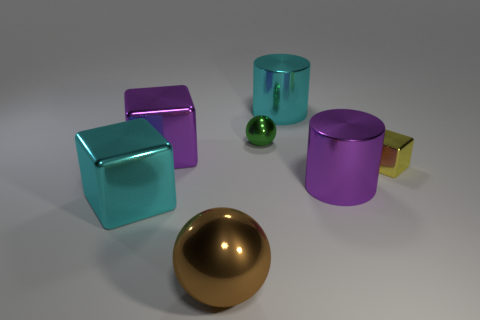Subtract all big cubes. How many cubes are left? 1 Add 1 shiny cylinders. How many objects exist? 8 Add 1 small metallic balls. How many small metallic balls are left? 2 Add 3 big gray metal cubes. How many big gray metal cubes exist? 3 Subtract 0 blue cylinders. How many objects are left? 7 Subtract all blocks. How many objects are left? 4 Subtract all brown cylinders. Subtract all big cyan cubes. How many objects are left? 6 